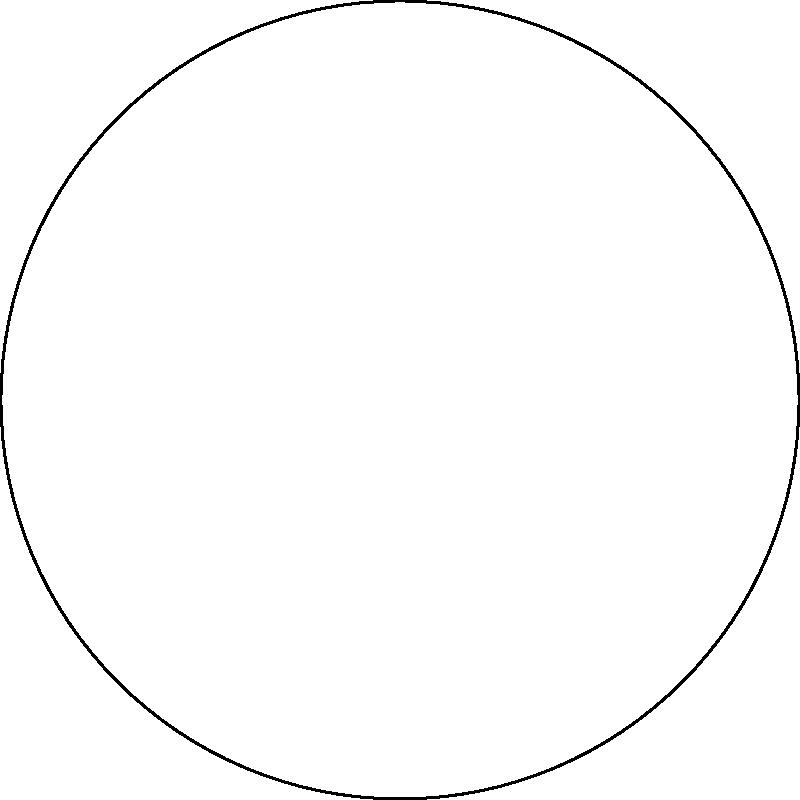A web developer is creating a circular navigation menu for a responsive website. The menu consists of 6 equally spaced items around a circle, as shown in the diagram. If the radius of the circle is 250 pixels, what is the x-coordinate of the third menu item (Item 3) relative to the center of the circle? Express your answer in pixels, rounded to the nearest whole number. To solve this problem, we'll follow these steps:

1) First, we need to determine the angle for each menu item. Since there are 6 items equally spaced around the circle, each item is separated by $\frac{360°}{6} = 60°$.

2) The third item (Item 3) will be positioned at an angle of $2 * 60° = 120°$ from the positive x-axis.

3) In a unit circle, the x-coordinate is given by the cosine of the angle. However, we need to adjust for the actual radius of our circle.

4) The formula for the x-coordinate is:

   $x = r * \cos(\theta)$

   Where $r$ is the radius and $\theta$ is the angle in radians.

5) We need to convert 120° to radians:
   
   $120° * \frac{\pi}{180°} = \frac{2\pi}{3}$ radians

6) Now we can plug in our values:

   $x = 250 * \cos(\frac{2\pi}{3})$

7) $\cos(\frac{2\pi}{3}) = -0.5$

8) Therefore:

   $x = 250 * (-0.5) = -125$

9) Rounding to the nearest whole number: -125 pixels.
Answer: -125 pixels 